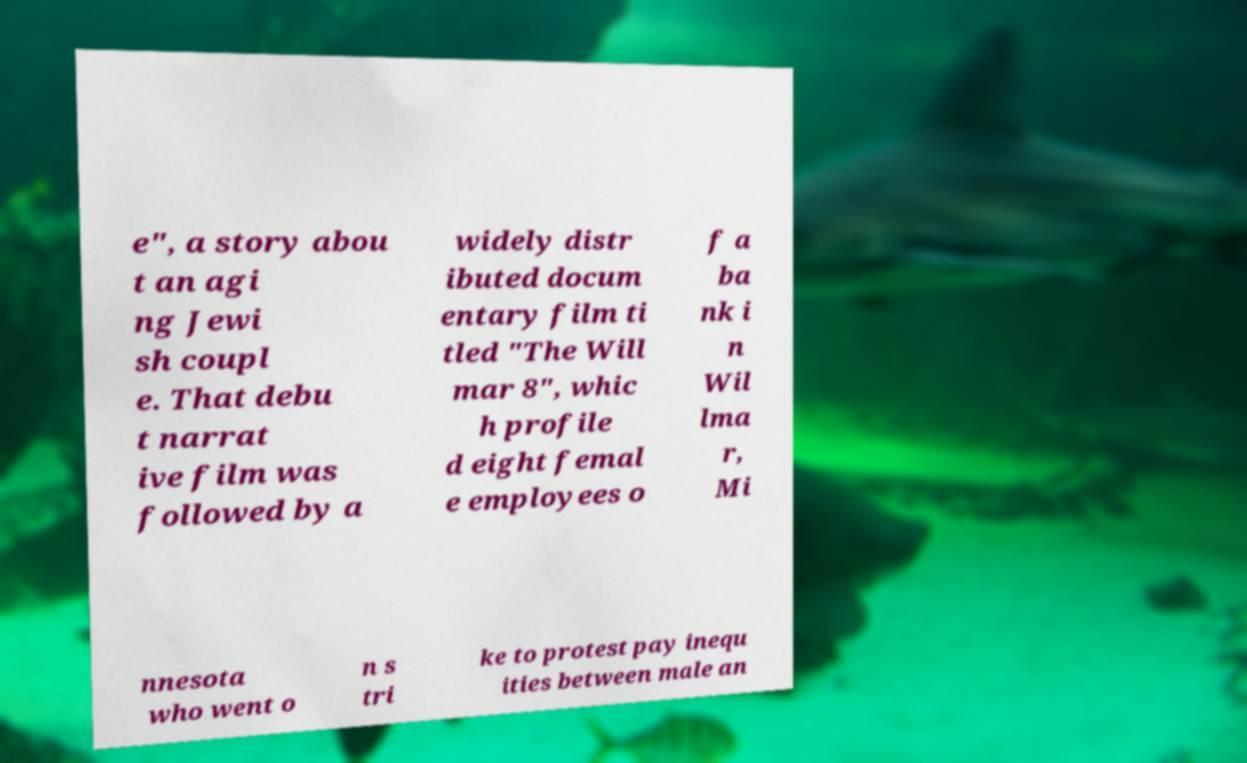Can you read and provide the text displayed in the image?This photo seems to have some interesting text. Can you extract and type it out for me? e", a story abou t an agi ng Jewi sh coupl e. That debu t narrat ive film was followed by a widely distr ibuted docum entary film ti tled "The Will mar 8", whic h profile d eight femal e employees o f a ba nk i n Wil lma r, Mi nnesota who went o n s tri ke to protest pay inequ ities between male an 